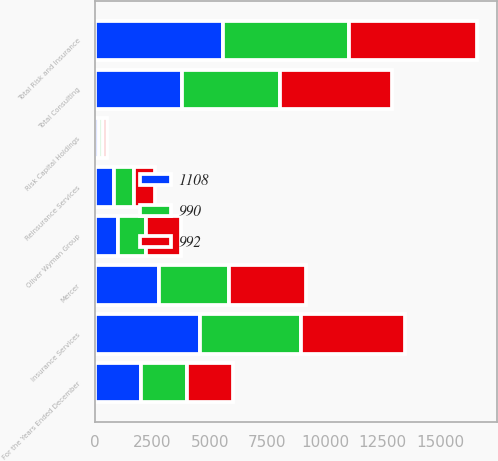<chart> <loc_0><loc_0><loc_500><loc_500><stacked_bar_chart><ecel><fcel>For the Years Ended December<fcel>Insurance Services<fcel>Reinsurance Services<fcel>Risk Capital Holdings<fcel>Total Risk and Insurance<fcel>Mercer<fcel>Oliver Wyman Group<fcel>Total Consulting<nl><fcel>992<fcel>2007<fcel>4500<fcel>902<fcel>163<fcel>5565<fcel>3368<fcel>1516<fcel>4884<nl><fcel>990<fcel>2006<fcel>4390<fcel>880<fcel>193<fcel>5463<fcel>3021<fcel>1204<fcel>4225<nl><fcel>1108<fcel>2005<fcel>4567<fcel>836<fcel>189<fcel>5592<fcel>2794<fcel>1008<fcel>3802<nl></chart> 